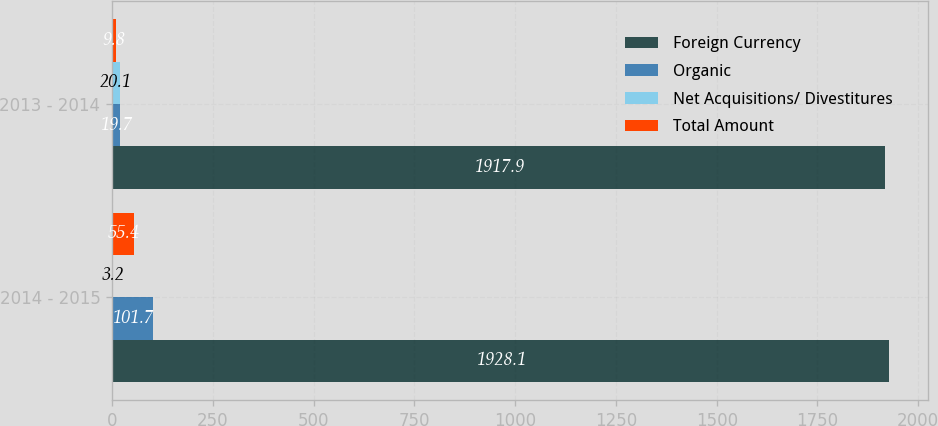<chart> <loc_0><loc_0><loc_500><loc_500><stacked_bar_chart><ecel><fcel>2014 - 2015<fcel>2013 - 2014<nl><fcel>Foreign Currency<fcel>1928.1<fcel>1917.9<nl><fcel>Organic<fcel>101.7<fcel>19.7<nl><fcel>Net Acquisitions/ Divestitures<fcel>3.2<fcel>20.1<nl><fcel>Total Amount<fcel>55.4<fcel>9.8<nl></chart> 